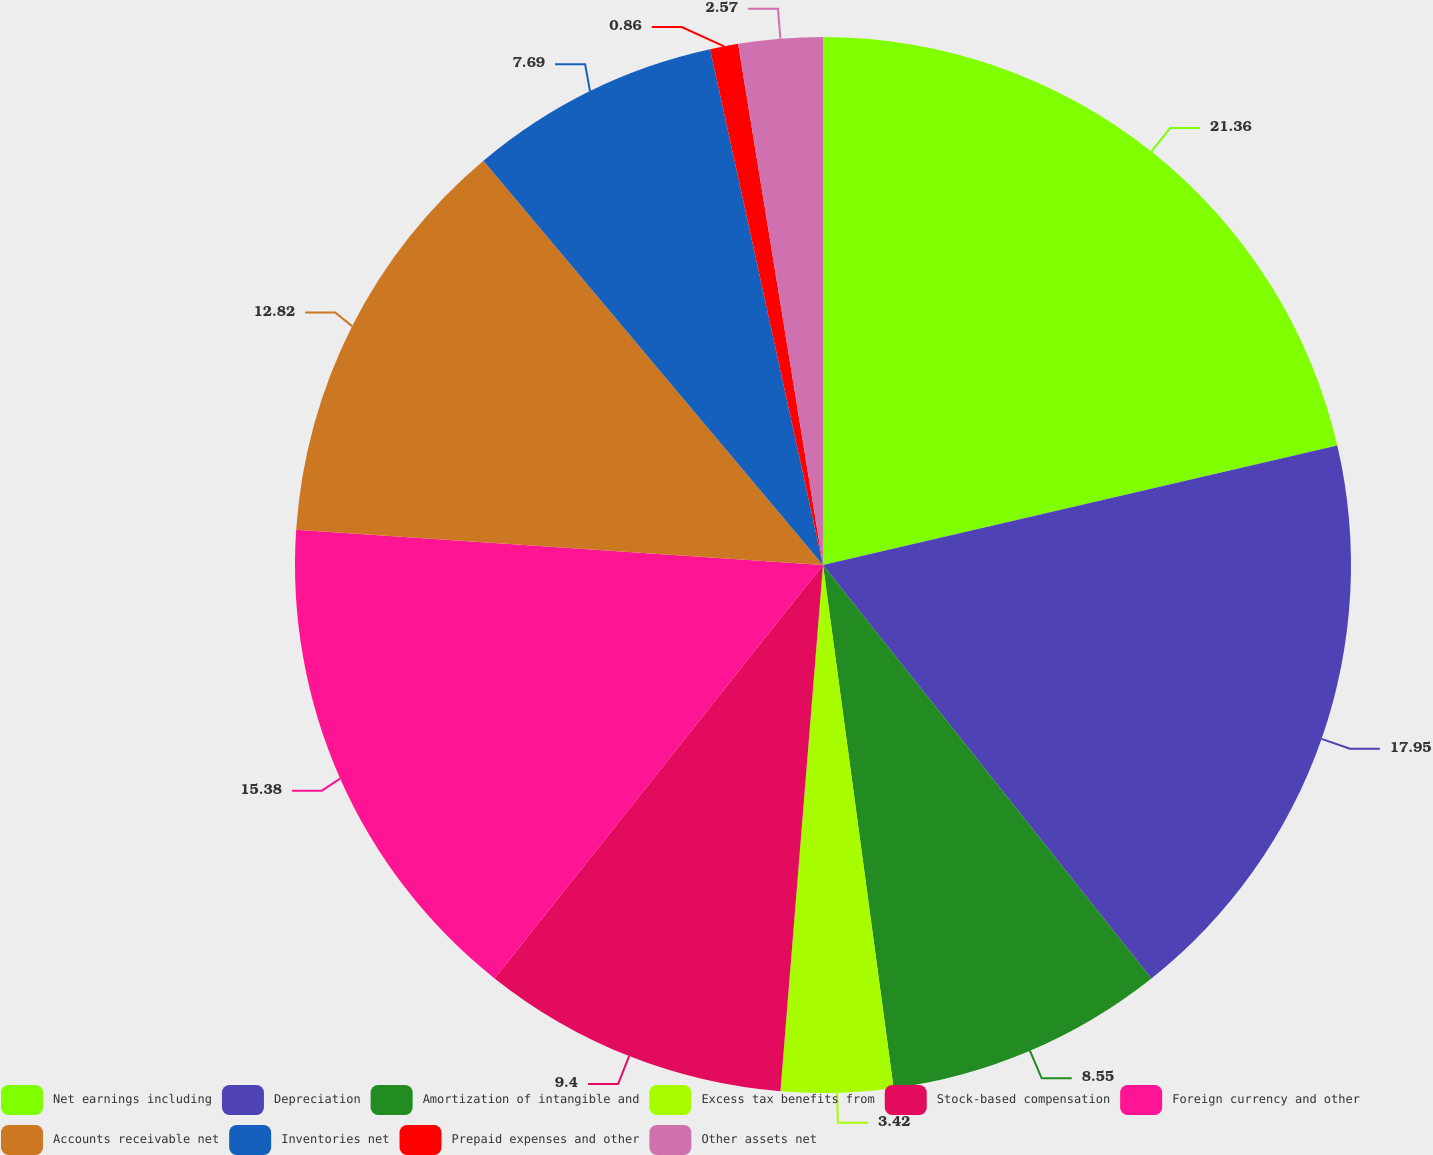<chart> <loc_0><loc_0><loc_500><loc_500><pie_chart><fcel>Net earnings including<fcel>Depreciation<fcel>Amortization of intangible and<fcel>Excess tax benefits from<fcel>Stock-based compensation<fcel>Foreign currency and other<fcel>Accounts receivable net<fcel>Inventories net<fcel>Prepaid expenses and other<fcel>Other assets net<nl><fcel>21.37%<fcel>17.95%<fcel>8.55%<fcel>3.42%<fcel>9.4%<fcel>15.38%<fcel>12.82%<fcel>7.69%<fcel>0.86%<fcel>2.57%<nl></chart> 